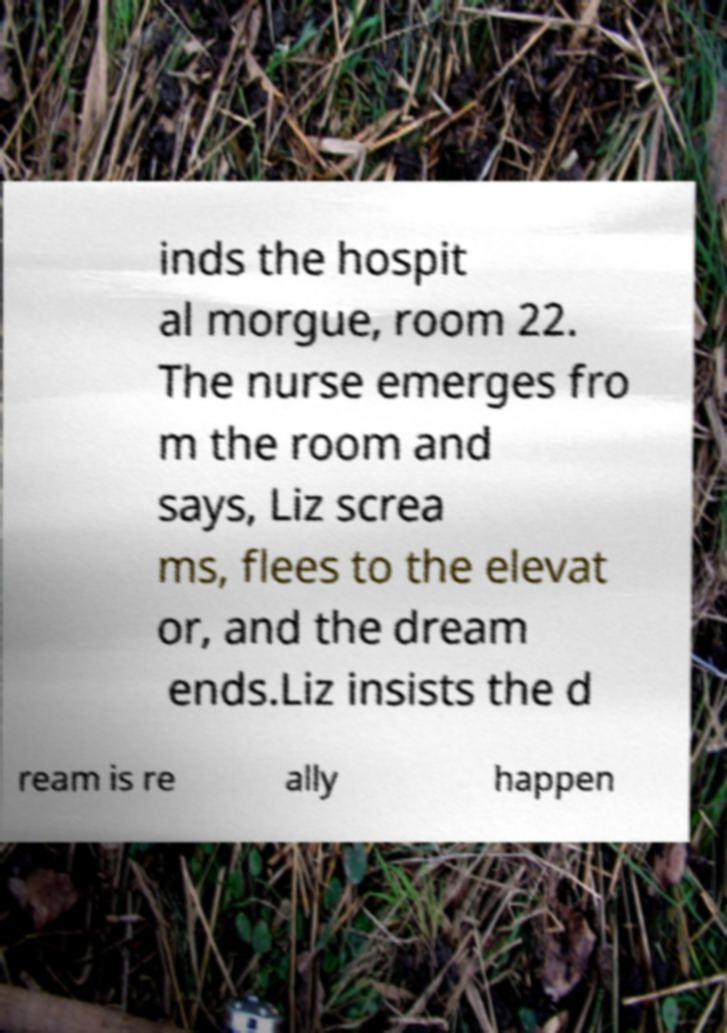Could you extract and type out the text from this image? inds the hospit al morgue, room 22. The nurse emerges fro m the room and says, Liz screa ms, flees to the elevat or, and the dream ends.Liz insists the d ream is re ally happen 